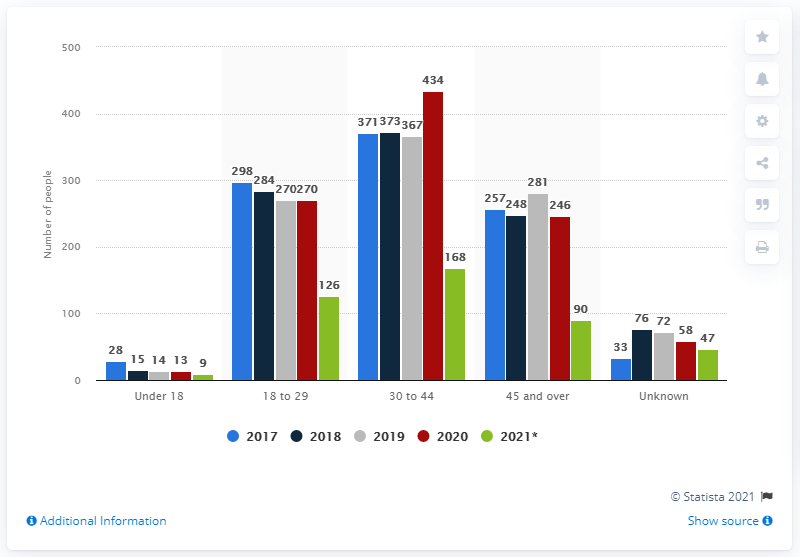Outline some significant characteristics in this image. In 2021, it is estimated that approximately 90 people were killed by U.S. law enforcement officers. 